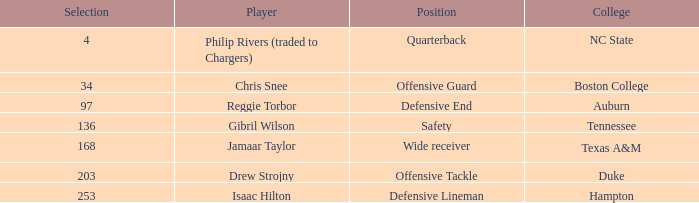Which Position has a Round larger than 5, and a Selection of 168? Wide receiver. 